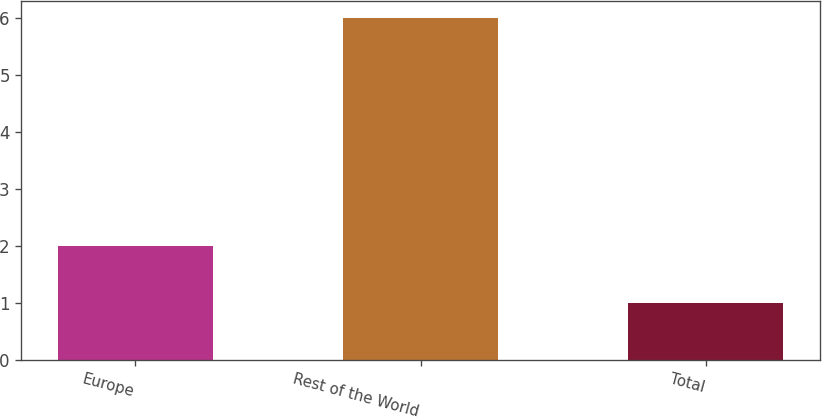<chart> <loc_0><loc_0><loc_500><loc_500><bar_chart><fcel>Europe<fcel>Rest of the World<fcel>Total<nl><fcel>2<fcel>6<fcel>1<nl></chart> 